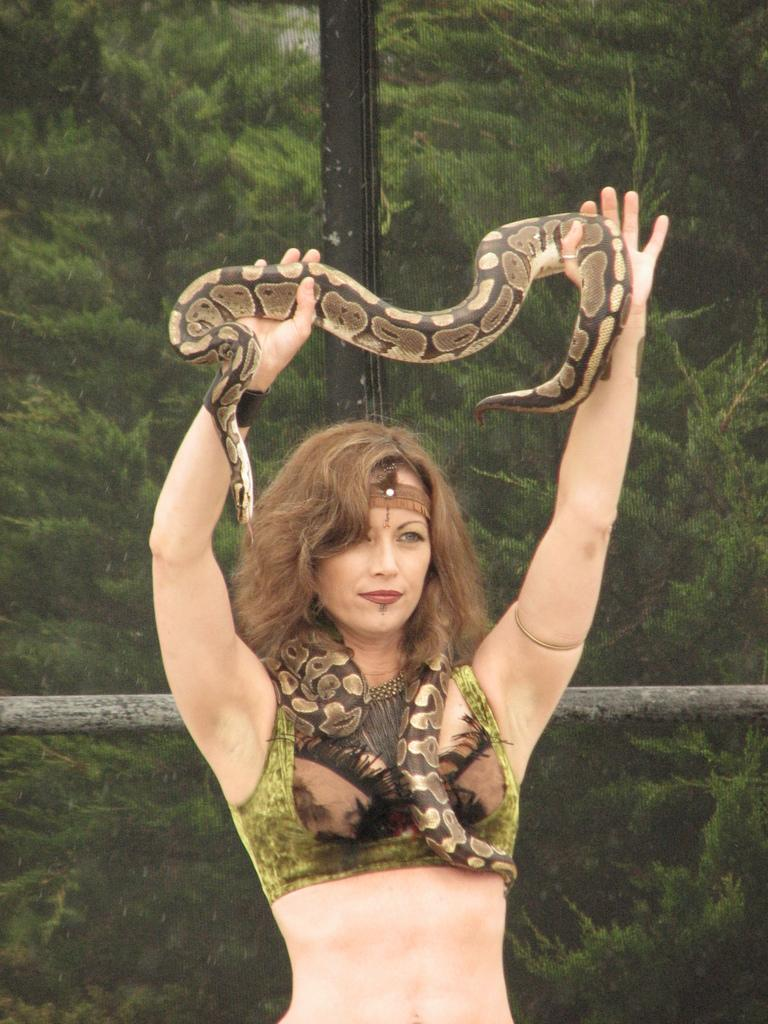Who is the main subject in the image? There is a woman in the image. What is the woman doing in the image? The woman is standing and holding a snake in her hands. What can be seen in the background of the image? There is a wooden pole in the background of the image. What type of discussion is taking place between the woman and the snake in the image? There is no discussion taking place between the woman and the snake in the image; the woman is simply holding the snake in her hands. 